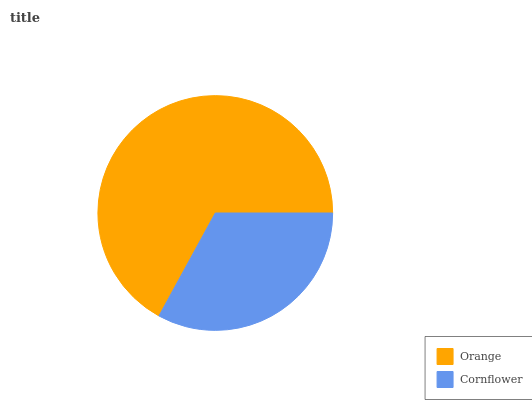Is Cornflower the minimum?
Answer yes or no. Yes. Is Orange the maximum?
Answer yes or no. Yes. Is Cornflower the maximum?
Answer yes or no. No. Is Orange greater than Cornflower?
Answer yes or no. Yes. Is Cornflower less than Orange?
Answer yes or no. Yes. Is Cornflower greater than Orange?
Answer yes or no. No. Is Orange less than Cornflower?
Answer yes or no. No. Is Orange the high median?
Answer yes or no. Yes. Is Cornflower the low median?
Answer yes or no. Yes. Is Cornflower the high median?
Answer yes or no. No. Is Orange the low median?
Answer yes or no. No. 